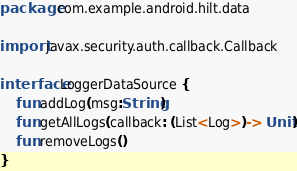Convert code to text. <code><loc_0><loc_0><loc_500><loc_500><_Kotlin_>package com.example.android.hilt.data

import javax.security.auth.callback.Callback

interface LoggerDataSource {
    fun addLog(msg:String)
    fun getAllLogs(callback: (List<Log>)-> Unit)
    fun removeLogs()
}</code> 